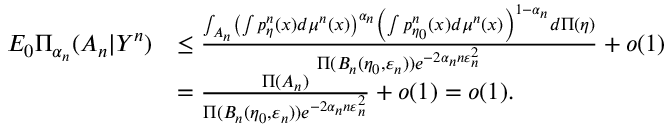Convert formula to latex. <formula><loc_0><loc_0><loc_500><loc_500>\begin{array} { r l } { E _ { 0 } \Pi _ { \alpha _ { n } } ( A _ { n } | Y ^ { n } ) } & { \leq \frac { \int _ { A _ { n } } \left ( \int p _ { \eta } ^ { n } ( x ) d \mu ^ { n } ( x ) \right ) ^ { \alpha _ { n } } \left ( \int p _ { \eta _ { 0 } } ^ { n } ( x ) d \mu ^ { n } ( x ) \right ) ^ { 1 - \alpha _ { n } } d \Pi ( \eta ) } { \Pi ( B _ { n } ( \eta _ { 0 } , \varepsilon _ { n } ) ) e ^ { - 2 { \alpha _ { n } } n \varepsilon _ { n } ^ { 2 } } } + o ( 1 ) } \\ & { = \frac { \Pi ( A _ { n } ) } { \Pi ( B _ { n } ( \eta _ { 0 } , \varepsilon _ { n } ) ) e ^ { - 2 { \alpha _ { n } } n \varepsilon _ { n } ^ { 2 } } } + o ( 1 ) = o ( 1 ) . } \end{array}</formula> 